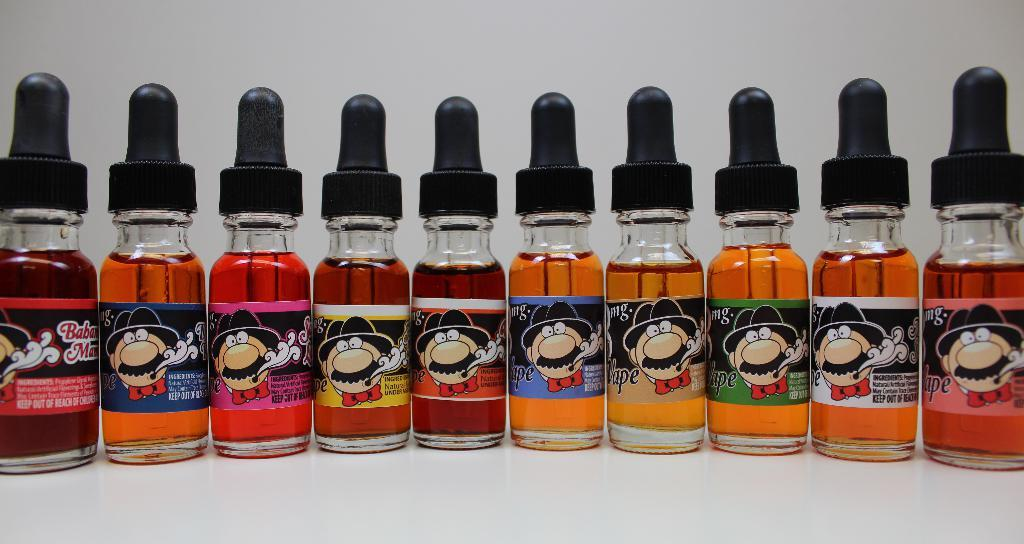What is the main subject of the image? The main subject of the image is many bottles. What can be found inside the bottles? The bottles contain different color solutions. Are there any identifying features on the bottles? Yes, there are labels on the bottles. What type of glass can be seen in the image? There is no glass present in the image; the image features bottles containing different color solutions. Can you describe the drawer in the image? There is no drawer present in the image; the image only shows bottles with different color solutions and labels. 